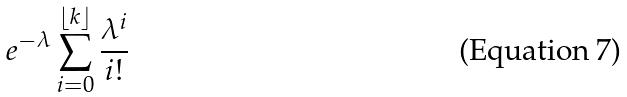<formula> <loc_0><loc_0><loc_500><loc_500>e ^ { - \lambda } \sum _ { i = 0 } ^ { \lfloor k \rfloor } \frac { \lambda ^ { i } } { i ! }</formula> 